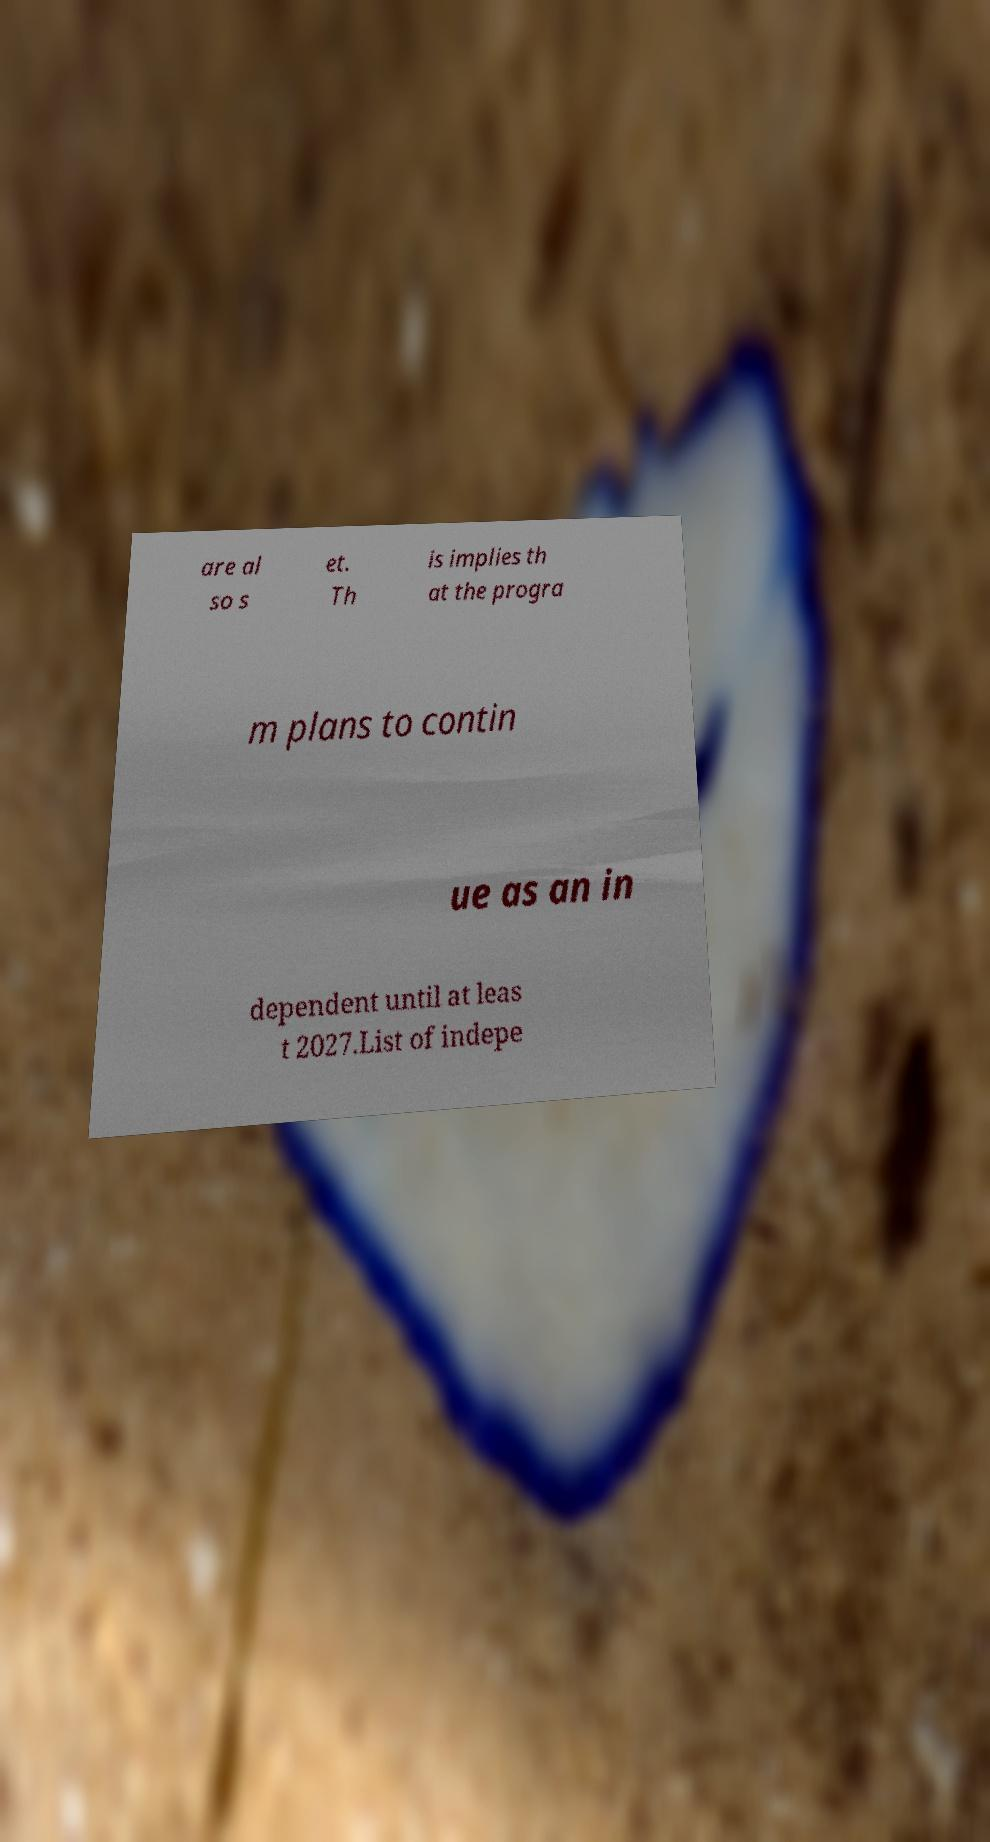I need the written content from this picture converted into text. Can you do that? are al so s et. Th is implies th at the progra m plans to contin ue as an in dependent until at leas t 2027.List of indepe 